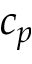Convert formula to latex. <formula><loc_0><loc_0><loc_500><loc_500>c _ { p }</formula> 